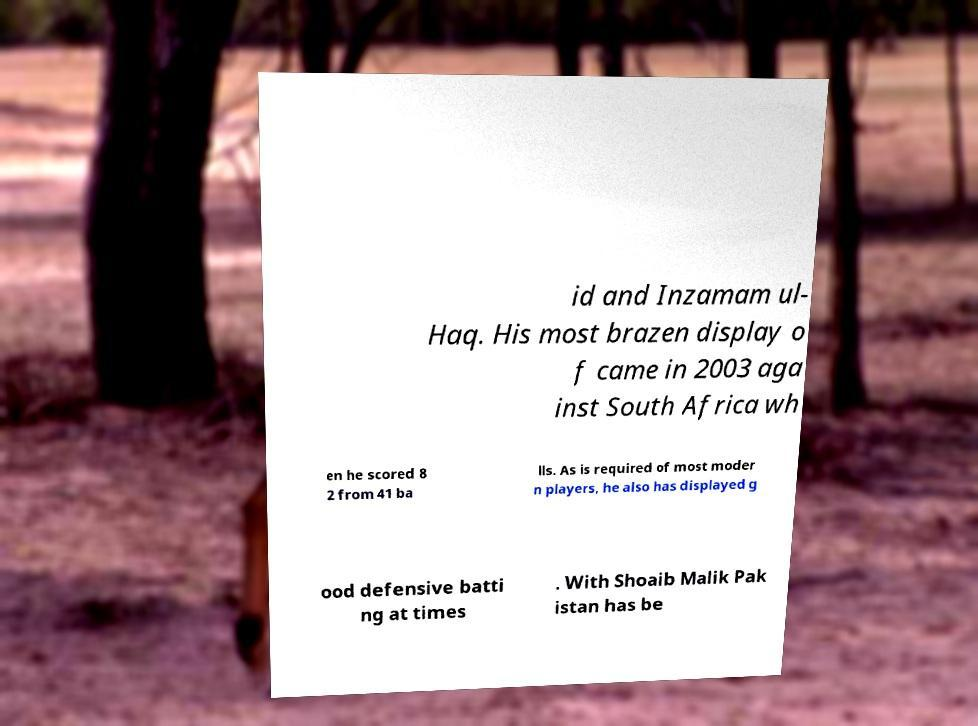Could you assist in decoding the text presented in this image and type it out clearly? id and Inzamam ul- Haq. His most brazen display o f came in 2003 aga inst South Africa wh en he scored 8 2 from 41 ba lls. As is required of most moder n players, he also has displayed g ood defensive batti ng at times . With Shoaib Malik Pak istan has be 